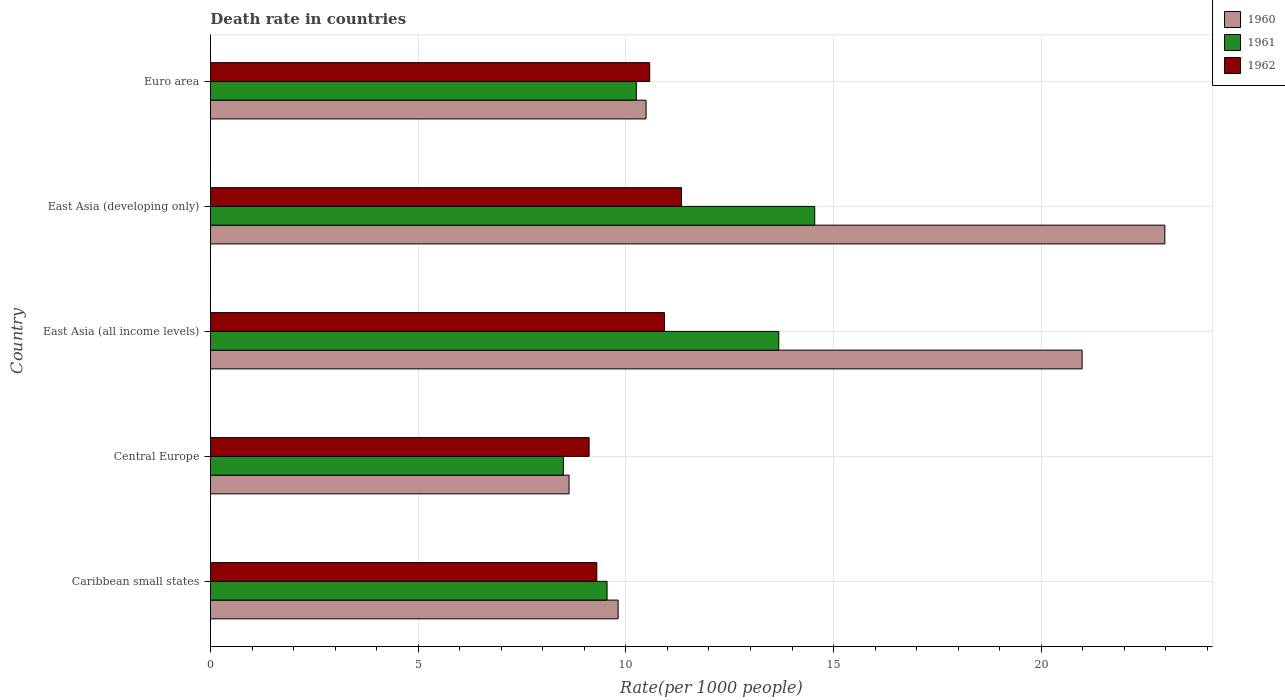How many groups of bars are there?
Offer a very short reply. 5. Are the number of bars on each tick of the Y-axis equal?
Provide a short and direct response. Yes. How many bars are there on the 4th tick from the top?
Keep it short and to the point. 3. What is the label of the 2nd group of bars from the top?
Your response must be concise. East Asia (developing only). What is the death rate in 1962 in East Asia (all income levels)?
Offer a terse response. 10.93. Across all countries, what is the maximum death rate in 1961?
Offer a very short reply. 14.55. Across all countries, what is the minimum death rate in 1962?
Provide a succinct answer. 9.11. In which country was the death rate in 1960 maximum?
Give a very brief answer. East Asia (developing only). In which country was the death rate in 1961 minimum?
Your answer should be very brief. Central Europe. What is the total death rate in 1962 in the graph?
Make the answer very short. 51.26. What is the difference between the death rate in 1962 in East Asia (developing only) and that in Euro area?
Ensure brevity in your answer.  0.77. What is the difference between the death rate in 1961 in East Asia (all income levels) and the death rate in 1960 in Central Europe?
Your answer should be very brief. 5.05. What is the average death rate in 1961 per country?
Your answer should be compact. 11.3. What is the difference between the death rate in 1962 and death rate in 1961 in Central Europe?
Keep it short and to the point. 0.62. What is the ratio of the death rate in 1962 in Caribbean small states to that in Central Europe?
Ensure brevity in your answer.  1.02. Is the death rate in 1962 in East Asia (all income levels) less than that in Euro area?
Your answer should be compact. No. Is the difference between the death rate in 1962 in East Asia (all income levels) and Euro area greater than the difference between the death rate in 1961 in East Asia (all income levels) and Euro area?
Ensure brevity in your answer.  No. What is the difference between the highest and the second highest death rate in 1961?
Your response must be concise. 0.86. What is the difference between the highest and the lowest death rate in 1962?
Your answer should be compact. 2.22. In how many countries, is the death rate in 1960 greater than the average death rate in 1960 taken over all countries?
Your response must be concise. 2. What does the 1st bar from the bottom in East Asia (all income levels) represents?
Ensure brevity in your answer.  1960. How many countries are there in the graph?
Offer a very short reply. 5. Does the graph contain any zero values?
Your answer should be compact. No. Where does the legend appear in the graph?
Give a very brief answer. Top right. What is the title of the graph?
Ensure brevity in your answer.  Death rate in countries. Does "1971" appear as one of the legend labels in the graph?
Keep it short and to the point. No. What is the label or title of the X-axis?
Make the answer very short. Rate(per 1000 people). What is the label or title of the Y-axis?
Keep it short and to the point. Country. What is the Rate(per 1000 people) of 1960 in Caribbean small states?
Offer a terse response. 9.81. What is the Rate(per 1000 people) in 1961 in Caribbean small states?
Offer a terse response. 9.55. What is the Rate(per 1000 people) of 1962 in Caribbean small states?
Your response must be concise. 9.3. What is the Rate(per 1000 people) in 1960 in Central Europe?
Provide a succinct answer. 8.63. What is the Rate(per 1000 people) of 1961 in Central Europe?
Provide a succinct answer. 8.5. What is the Rate(per 1000 people) in 1962 in Central Europe?
Offer a very short reply. 9.11. What is the Rate(per 1000 people) in 1960 in East Asia (all income levels)?
Your response must be concise. 20.98. What is the Rate(per 1000 people) in 1961 in East Asia (all income levels)?
Your answer should be very brief. 13.68. What is the Rate(per 1000 people) of 1962 in East Asia (all income levels)?
Your response must be concise. 10.93. What is the Rate(per 1000 people) of 1960 in East Asia (developing only)?
Offer a very short reply. 22.97. What is the Rate(per 1000 people) of 1961 in East Asia (developing only)?
Your response must be concise. 14.55. What is the Rate(per 1000 people) of 1962 in East Asia (developing only)?
Your answer should be compact. 11.34. What is the Rate(per 1000 people) of 1960 in Euro area?
Make the answer very short. 10.49. What is the Rate(per 1000 people) of 1961 in Euro area?
Ensure brevity in your answer.  10.25. What is the Rate(per 1000 people) in 1962 in Euro area?
Provide a short and direct response. 10.57. Across all countries, what is the maximum Rate(per 1000 people) of 1960?
Keep it short and to the point. 22.97. Across all countries, what is the maximum Rate(per 1000 people) in 1961?
Provide a succinct answer. 14.55. Across all countries, what is the maximum Rate(per 1000 people) of 1962?
Provide a short and direct response. 11.34. Across all countries, what is the minimum Rate(per 1000 people) of 1960?
Ensure brevity in your answer.  8.63. Across all countries, what is the minimum Rate(per 1000 people) of 1961?
Provide a short and direct response. 8.5. Across all countries, what is the minimum Rate(per 1000 people) of 1962?
Provide a succinct answer. 9.11. What is the total Rate(per 1000 people) of 1960 in the graph?
Your answer should be compact. 72.89. What is the total Rate(per 1000 people) of 1961 in the graph?
Offer a terse response. 56.52. What is the total Rate(per 1000 people) in 1962 in the graph?
Keep it short and to the point. 51.26. What is the difference between the Rate(per 1000 people) of 1960 in Caribbean small states and that in Central Europe?
Keep it short and to the point. 1.18. What is the difference between the Rate(per 1000 people) in 1961 in Caribbean small states and that in Central Europe?
Keep it short and to the point. 1.05. What is the difference between the Rate(per 1000 people) in 1962 in Caribbean small states and that in Central Europe?
Your answer should be very brief. 0.19. What is the difference between the Rate(per 1000 people) in 1960 in Caribbean small states and that in East Asia (all income levels)?
Ensure brevity in your answer.  -11.17. What is the difference between the Rate(per 1000 people) in 1961 in Caribbean small states and that in East Asia (all income levels)?
Offer a terse response. -4.13. What is the difference between the Rate(per 1000 people) of 1962 in Caribbean small states and that in East Asia (all income levels)?
Your response must be concise. -1.63. What is the difference between the Rate(per 1000 people) of 1960 in Caribbean small states and that in East Asia (developing only)?
Your answer should be compact. -13.16. What is the difference between the Rate(per 1000 people) in 1961 in Caribbean small states and that in East Asia (developing only)?
Ensure brevity in your answer.  -5. What is the difference between the Rate(per 1000 people) in 1962 in Caribbean small states and that in East Asia (developing only)?
Offer a very short reply. -2.04. What is the difference between the Rate(per 1000 people) of 1960 in Caribbean small states and that in Euro area?
Give a very brief answer. -0.67. What is the difference between the Rate(per 1000 people) of 1961 in Caribbean small states and that in Euro area?
Ensure brevity in your answer.  -0.7. What is the difference between the Rate(per 1000 people) of 1962 in Caribbean small states and that in Euro area?
Ensure brevity in your answer.  -1.27. What is the difference between the Rate(per 1000 people) in 1960 in Central Europe and that in East Asia (all income levels)?
Make the answer very short. -12.35. What is the difference between the Rate(per 1000 people) in 1961 in Central Europe and that in East Asia (all income levels)?
Give a very brief answer. -5.19. What is the difference between the Rate(per 1000 people) in 1962 in Central Europe and that in East Asia (all income levels)?
Provide a short and direct response. -1.81. What is the difference between the Rate(per 1000 people) of 1960 in Central Europe and that in East Asia (developing only)?
Your answer should be very brief. -14.34. What is the difference between the Rate(per 1000 people) of 1961 in Central Europe and that in East Asia (developing only)?
Keep it short and to the point. -6.05. What is the difference between the Rate(per 1000 people) of 1962 in Central Europe and that in East Asia (developing only)?
Keep it short and to the point. -2.22. What is the difference between the Rate(per 1000 people) of 1960 in Central Europe and that in Euro area?
Provide a succinct answer. -1.85. What is the difference between the Rate(per 1000 people) in 1961 in Central Europe and that in Euro area?
Your answer should be very brief. -1.76. What is the difference between the Rate(per 1000 people) in 1962 in Central Europe and that in Euro area?
Your answer should be very brief. -1.46. What is the difference between the Rate(per 1000 people) of 1960 in East Asia (all income levels) and that in East Asia (developing only)?
Your answer should be very brief. -1.99. What is the difference between the Rate(per 1000 people) of 1961 in East Asia (all income levels) and that in East Asia (developing only)?
Offer a very short reply. -0.86. What is the difference between the Rate(per 1000 people) in 1962 in East Asia (all income levels) and that in East Asia (developing only)?
Make the answer very short. -0.41. What is the difference between the Rate(per 1000 people) of 1960 in East Asia (all income levels) and that in Euro area?
Make the answer very short. 10.5. What is the difference between the Rate(per 1000 people) of 1961 in East Asia (all income levels) and that in Euro area?
Your response must be concise. 3.43. What is the difference between the Rate(per 1000 people) in 1962 in East Asia (all income levels) and that in Euro area?
Your response must be concise. 0.35. What is the difference between the Rate(per 1000 people) in 1960 in East Asia (developing only) and that in Euro area?
Give a very brief answer. 12.49. What is the difference between the Rate(per 1000 people) of 1961 in East Asia (developing only) and that in Euro area?
Offer a very short reply. 4.29. What is the difference between the Rate(per 1000 people) in 1962 in East Asia (developing only) and that in Euro area?
Make the answer very short. 0.77. What is the difference between the Rate(per 1000 people) in 1960 in Caribbean small states and the Rate(per 1000 people) in 1961 in Central Europe?
Provide a short and direct response. 1.32. What is the difference between the Rate(per 1000 people) in 1960 in Caribbean small states and the Rate(per 1000 people) in 1962 in Central Europe?
Provide a succinct answer. 0.7. What is the difference between the Rate(per 1000 people) in 1961 in Caribbean small states and the Rate(per 1000 people) in 1962 in Central Europe?
Make the answer very short. 0.43. What is the difference between the Rate(per 1000 people) of 1960 in Caribbean small states and the Rate(per 1000 people) of 1961 in East Asia (all income levels)?
Your answer should be compact. -3.87. What is the difference between the Rate(per 1000 people) in 1960 in Caribbean small states and the Rate(per 1000 people) in 1962 in East Asia (all income levels)?
Give a very brief answer. -1.12. What is the difference between the Rate(per 1000 people) in 1961 in Caribbean small states and the Rate(per 1000 people) in 1962 in East Asia (all income levels)?
Provide a short and direct response. -1.38. What is the difference between the Rate(per 1000 people) in 1960 in Caribbean small states and the Rate(per 1000 people) in 1961 in East Asia (developing only)?
Give a very brief answer. -4.73. What is the difference between the Rate(per 1000 people) of 1960 in Caribbean small states and the Rate(per 1000 people) of 1962 in East Asia (developing only)?
Ensure brevity in your answer.  -1.53. What is the difference between the Rate(per 1000 people) of 1961 in Caribbean small states and the Rate(per 1000 people) of 1962 in East Asia (developing only)?
Give a very brief answer. -1.79. What is the difference between the Rate(per 1000 people) in 1960 in Caribbean small states and the Rate(per 1000 people) in 1961 in Euro area?
Offer a terse response. -0.44. What is the difference between the Rate(per 1000 people) in 1960 in Caribbean small states and the Rate(per 1000 people) in 1962 in Euro area?
Your answer should be very brief. -0.76. What is the difference between the Rate(per 1000 people) in 1961 in Caribbean small states and the Rate(per 1000 people) in 1962 in Euro area?
Give a very brief answer. -1.03. What is the difference between the Rate(per 1000 people) in 1960 in Central Europe and the Rate(per 1000 people) in 1961 in East Asia (all income levels)?
Ensure brevity in your answer.  -5.05. What is the difference between the Rate(per 1000 people) of 1960 in Central Europe and the Rate(per 1000 people) of 1962 in East Asia (all income levels)?
Your answer should be compact. -2.3. What is the difference between the Rate(per 1000 people) of 1961 in Central Europe and the Rate(per 1000 people) of 1962 in East Asia (all income levels)?
Provide a short and direct response. -2.43. What is the difference between the Rate(per 1000 people) in 1960 in Central Europe and the Rate(per 1000 people) in 1961 in East Asia (developing only)?
Your answer should be very brief. -5.91. What is the difference between the Rate(per 1000 people) in 1960 in Central Europe and the Rate(per 1000 people) in 1962 in East Asia (developing only)?
Offer a very short reply. -2.71. What is the difference between the Rate(per 1000 people) in 1961 in Central Europe and the Rate(per 1000 people) in 1962 in East Asia (developing only)?
Provide a short and direct response. -2.84. What is the difference between the Rate(per 1000 people) in 1960 in Central Europe and the Rate(per 1000 people) in 1961 in Euro area?
Ensure brevity in your answer.  -1.62. What is the difference between the Rate(per 1000 people) in 1960 in Central Europe and the Rate(per 1000 people) in 1962 in Euro area?
Ensure brevity in your answer.  -1.94. What is the difference between the Rate(per 1000 people) in 1961 in Central Europe and the Rate(per 1000 people) in 1962 in Euro area?
Ensure brevity in your answer.  -2.08. What is the difference between the Rate(per 1000 people) in 1960 in East Asia (all income levels) and the Rate(per 1000 people) in 1961 in East Asia (developing only)?
Your answer should be compact. 6.44. What is the difference between the Rate(per 1000 people) of 1960 in East Asia (all income levels) and the Rate(per 1000 people) of 1962 in East Asia (developing only)?
Your answer should be very brief. 9.64. What is the difference between the Rate(per 1000 people) in 1961 in East Asia (all income levels) and the Rate(per 1000 people) in 1962 in East Asia (developing only)?
Ensure brevity in your answer.  2.34. What is the difference between the Rate(per 1000 people) of 1960 in East Asia (all income levels) and the Rate(per 1000 people) of 1961 in Euro area?
Provide a succinct answer. 10.73. What is the difference between the Rate(per 1000 people) of 1960 in East Asia (all income levels) and the Rate(per 1000 people) of 1962 in Euro area?
Offer a very short reply. 10.41. What is the difference between the Rate(per 1000 people) in 1961 in East Asia (all income levels) and the Rate(per 1000 people) in 1962 in Euro area?
Give a very brief answer. 3.11. What is the difference between the Rate(per 1000 people) of 1960 in East Asia (developing only) and the Rate(per 1000 people) of 1961 in Euro area?
Offer a terse response. 12.72. What is the difference between the Rate(per 1000 people) in 1960 in East Asia (developing only) and the Rate(per 1000 people) in 1962 in Euro area?
Offer a very short reply. 12.4. What is the difference between the Rate(per 1000 people) of 1961 in East Asia (developing only) and the Rate(per 1000 people) of 1962 in Euro area?
Provide a succinct answer. 3.97. What is the average Rate(per 1000 people) of 1960 per country?
Your answer should be compact. 14.58. What is the average Rate(per 1000 people) of 1961 per country?
Offer a very short reply. 11.3. What is the average Rate(per 1000 people) of 1962 per country?
Offer a terse response. 10.25. What is the difference between the Rate(per 1000 people) of 1960 and Rate(per 1000 people) of 1961 in Caribbean small states?
Your answer should be very brief. 0.27. What is the difference between the Rate(per 1000 people) in 1960 and Rate(per 1000 people) in 1962 in Caribbean small states?
Provide a succinct answer. 0.51. What is the difference between the Rate(per 1000 people) of 1961 and Rate(per 1000 people) of 1962 in Caribbean small states?
Ensure brevity in your answer.  0.25. What is the difference between the Rate(per 1000 people) of 1960 and Rate(per 1000 people) of 1961 in Central Europe?
Provide a short and direct response. 0.14. What is the difference between the Rate(per 1000 people) in 1960 and Rate(per 1000 people) in 1962 in Central Europe?
Offer a very short reply. -0.48. What is the difference between the Rate(per 1000 people) in 1961 and Rate(per 1000 people) in 1962 in Central Europe?
Keep it short and to the point. -0.62. What is the difference between the Rate(per 1000 people) in 1960 and Rate(per 1000 people) in 1961 in East Asia (all income levels)?
Provide a succinct answer. 7.3. What is the difference between the Rate(per 1000 people) of 1960 and Rate(per 1000 people) of 1962 in East Asia (all income levels)?
Keep it short and to the point. 10.05. What is the difference between the Rate(per 1000 people) of 1961 and Rate(per 1000 people) of 1962 in East Asia (all income levels)?
Keep it short and to the point. 2.75. What is the difference between the Rate(per 1000 people) in 1960 and Rate(per 1000 people) in 1961 in East Asia (developing only)?
Provide a short and direct response. 8.43. What is the difference between the Rate(per 1000 people) in 1960 and Rate(per 1000 people) in 1962 in East Asia (developing only)?
Keep it short and to the point. 11.63. What is the difference between the Rate(per 1000 people) in 1961 and Rate(per 1000 people) in 1962 in East Asia (developing only)?
Offer a very short reply. 3.21. What is the difference between the Rate(per 1000 people) of 1960 and Rate(per 1000 people) of 1961 in Euro area?
Your answer should be compact. 0.23. What is the difference between the Rate(per 1000 people) in 1960 and Rate(per 1000 people) in 1962 in Euro area?
Ensure brevity in your answer.  -0.09. What is the difference between the Rate(per 1000 people) in 1961 and Rate(per 1000 people) in 1962 in Euro area?
Make the answer very short. -0.32. What is the ratio of the Rate(per 1000 people) of 1960 in Caribbean small states to that in Central Europe?
Make the answer very short. 1.14. What is the ratio of the Rate(per 1000 people) of 1961 in Caribbean small states to that in Central Europe?
Ensure brevity in your answer.  1.12. What is the ratio of the Rate(per 1000 people) of 1962 in Caribbean small states to that in Central Europe?
Provide a short and direct response. 1.02. What is the ratio of the Rate(per 1000 people) of 1960 in Caribbean small states to that in East Asia (all income levels)?
Offer a very short reply. 0.47. What is the ratio of the Rate(per 1000 people) of 1961 in Caribbean small states to that in East Asia (all income levels)?
Your response must be concise. 0.7. What is the ratio of the Rate(per 1000 people) of 1962 in Caribbean small states to that in East Asia (all income levels)?
Keep it short and to the point. 0.85. What is the ratio of the Rate(per 1000 people) of 1960 in Caribbean small states to that in East Asia (developing only)?
Your answer should be very brief. 0.43. What is the ratio of the Rate(per 1000 people) of 1961 in Caribbean small states to that in East Asia (developing only)?
Offer a very short reply. 0.66. What is the ratio of the Rate(per 1000 people) of 1962 in Caribbean small states to that in East Asia (developing only)?
Offer a terse response. 0.82. What is the ratio of the Rate(per 1000 people) in 1960 in Caribbean small states to that in Euro area?
Offer a very short reply. 0.94. What is the ratio of the Rate(per 1000 people) of 1961 in Caribbean small states to that in Euro area?
Give a very brief answer. 0.93. What is the ratio of the Rate(per 1000 people) of 1962 in Caribbean small states to that in Euro area?
Offer a very short reply. 0.88. What is the ratio of the Rate(per 1000 people) in 1960 in Central Europe to that in East Asia (all income levels)?
Ensure brevity in your answer.  0.41. What is the ratio of the Rate(per 1000 people) in 1961 in Central Europe to that in East Asia (all income levels)?
Ensure brevity in your answer.  0.62. What is the ratio of the Rate(per 1000 people) of 1962 in Central Europe to that in East Asia (all income levels)?
Give a very brief answer. 0.83. What is the ratio of the Rate(per 1000 people) in 1960 in Central Europe to that in East Asia (developing only)?
Offer a terse response. 0.38. What is the ratio of the Rate(per 1000 people) of 1961 in Central Europe to that in East Asia (developing only)?
Provide a succinct answer. 0.58. What is the ratio of the Rate(per 1000 people) in 1962 in Central Europe to that in East Asia (developing only)?
Your response must be concise. 0.8. What is the ratio of the Rate(per 1000 people) of 1960 in Central Europe to that in Euro area?
Your answer should be compact. 0.82. What is the ratio of the Rate(per 1000 people) of 1961 in Central Europe to that in Euro area?
Ensure brevity in your answer.  0.83. What is the ratio of the Rate(per 1000 people) in 1962 in Central Europe to that in Euro area?
Offer a very short reply. 0.86. What is the ratio of the Rate(per 1000 people) in 1960 in East Asia (all income levels) to that in East Asia (developing only)?
Offer a very short reply. 0.91. What is the ratio of the Rate(per 1000 people) of 1961 in East Asia (all income levels) to that in East Asia (developing only)?
Offer a terse response. 0.94. What is the ratio of the Rate(per 1000 people) in 1962 in East Asia (all income levels) to that in East Asia (developing only)?
Provide a succinct answer. 0.96. What is the ratio of the Rate(per 1000 people) in 1960 in East Asia (all income levels) to that in Euro area?
Offer a terse response. 2. What is the ratio of the Rate(per 1000 people) in 1961 in East Asia (all income levels) to that in Euro area?
Provide a succinct answer. 1.33. What is the ratio of the Rate(per 1000 people) in 1962 in East Asia (all income levels) to that in Euro area?
Ensure brevity in your answer.  1.03. What is the ratio of the Rate(per 1000 people) in 1960 in East Asia (developing only) to that in Euro area?
Provide a short and direct response. 2.19. What is the ratio of the Rate(per 1000 people) of 1961 in East Asia (developing only) to that in Euro area?
Keep it short and to the point. 1.42. What is the ratio of the Rate(per 1000 people) in 1962 in East Asia (developing only) to that in Euro area?
Keep it short and to the point. 1.07. What is the difference between the highest and the second highest Rate(per 1000 people) of 1960?
Keep it short and to the point. 1.99. What is the difference between the highest and the second highest Rate(per 1000 people) in 1961?
Provide a short and direct response. 0.86. What is the difference between the highest and the second highest Rate(per 1000 people) of 1962?
Provide a short and direct response. 0.41. What is the difference between the highest and the lowest Rate(per 1000 people) of 1960?
Make the answer very short. 14.34. What is the difference between the highest and the lowest Rate(per 1000 people) in 1961?
Provide a succinct answer. 6.05. What is the difference between the highest and the lowest Rate(per 1000 people) of 1962?
Your response must be concise. 2.22. 